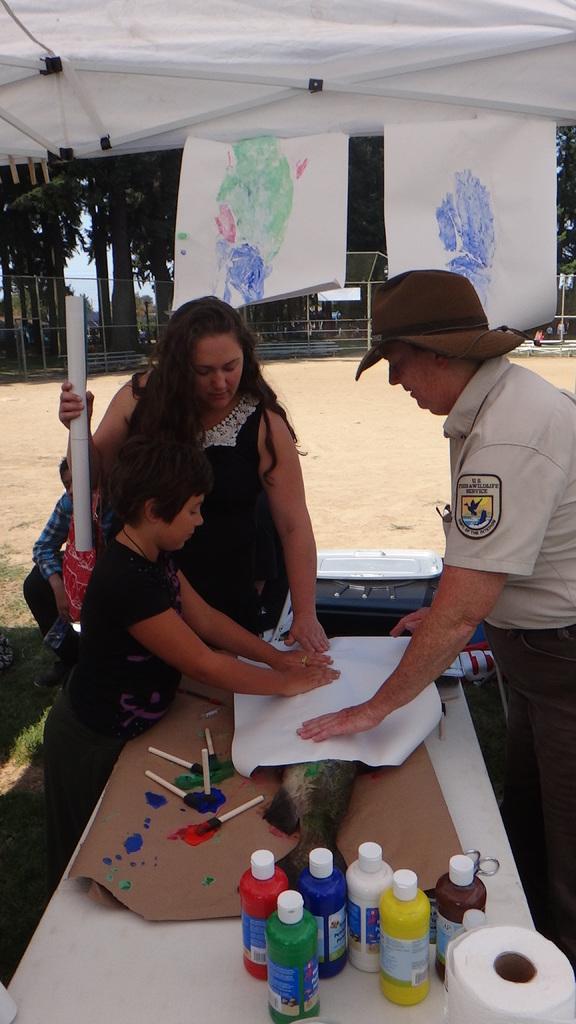Please provide a concise description of this image. In this image we can see few people. There are few objects on the table. A person is wearing a hat at the right side of the image. There is a tent in the image. There is a fence in the image. There are many trees in the image. We can see the sky in the image. 